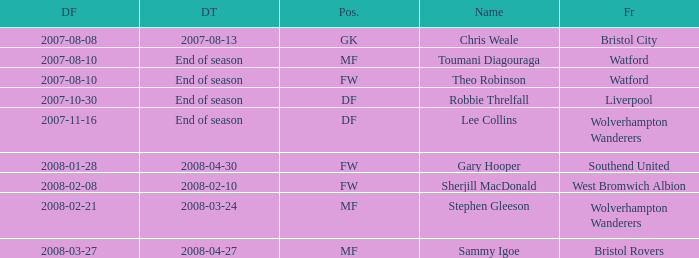Where was the player from who had the position of DF, who started 2007-10-30? Liverpool. 